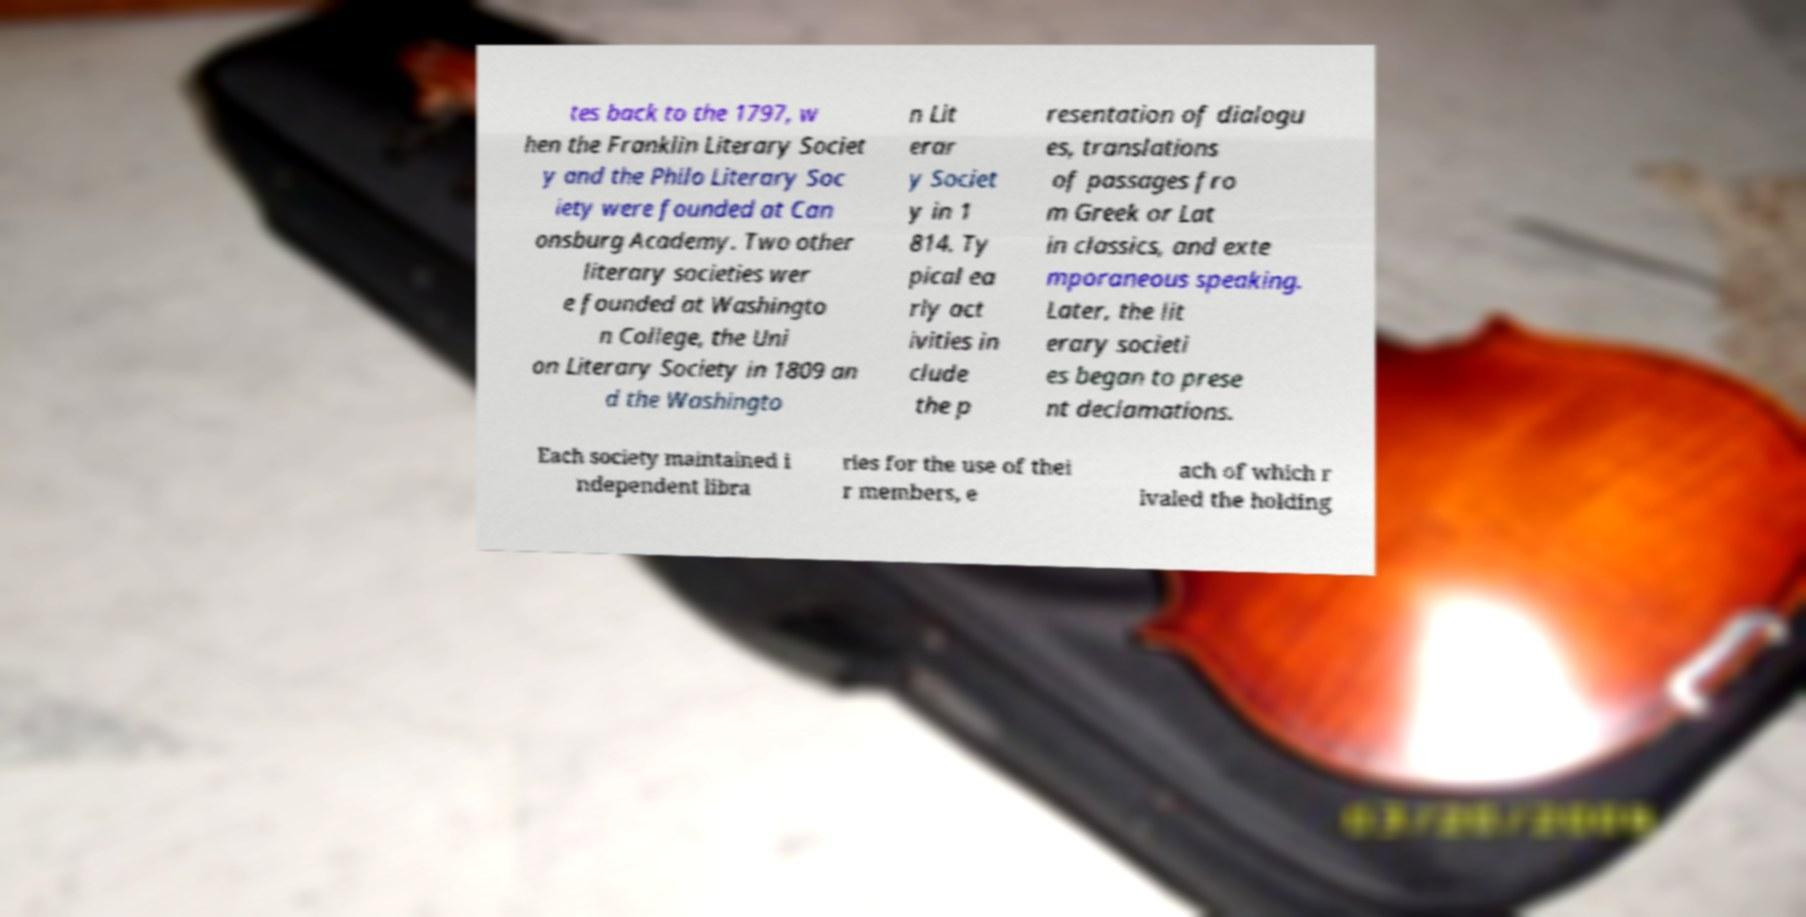I need the written content from this picture converted into text. Can you do that? tes back to the 1797, w hen the Franklin Literary Societ y and the Philo Literary Soc iety were founded at Can onsburg Academy. Two other literary societies wer e founded at Washingto n College, the Uni on Literary Society in 1809 an d the Washingto n Lit erar y Societ y in 1 814. Ty pical ea rly act ivities in clude the p resentation of dialogu es, translations of passages fro m Greek or Lat in classics, and exte mporaneous speaking. Later, the lit erary societi es began to prese nt declamations. Each society maintained i ndependent libra ries for the use of thei r members, e ach of which r ivaled the holding 